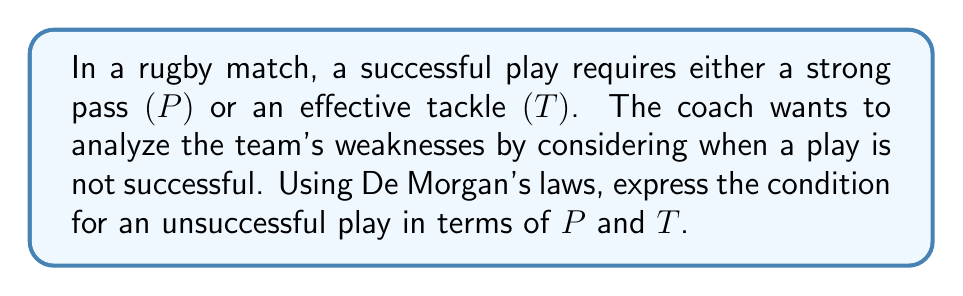Give your solution to this math problem. Let's approach this step-by-step:

1) First, we define our variables:
   $P$: Strong pass
   $T$: Effective tackle

2) A successful play is represented by the Boolean expression:
   $$(P \lor T)$$

3) An unsuccessful play would be the negation of a successful play:
   $$\neg(P \lor T)$$

4) Now, we can apply De Morgan's law to this expression. De Morgan's law states that:
   $$\neg(A \lor B) = \neg A \land \neg B$$

5) Applying this to our expression:
   $$\neg(P \lor T) = \neg P \land \neg T$$

6) This means that a play is unsuccessful when there is neither a strong pass nor an effective tackle.

7) In rugby terms, this translates to: a play is unsuccessful when the pass is weak AND the tackle is ineffective.
Answer: $\neg P \land \neg T$ 